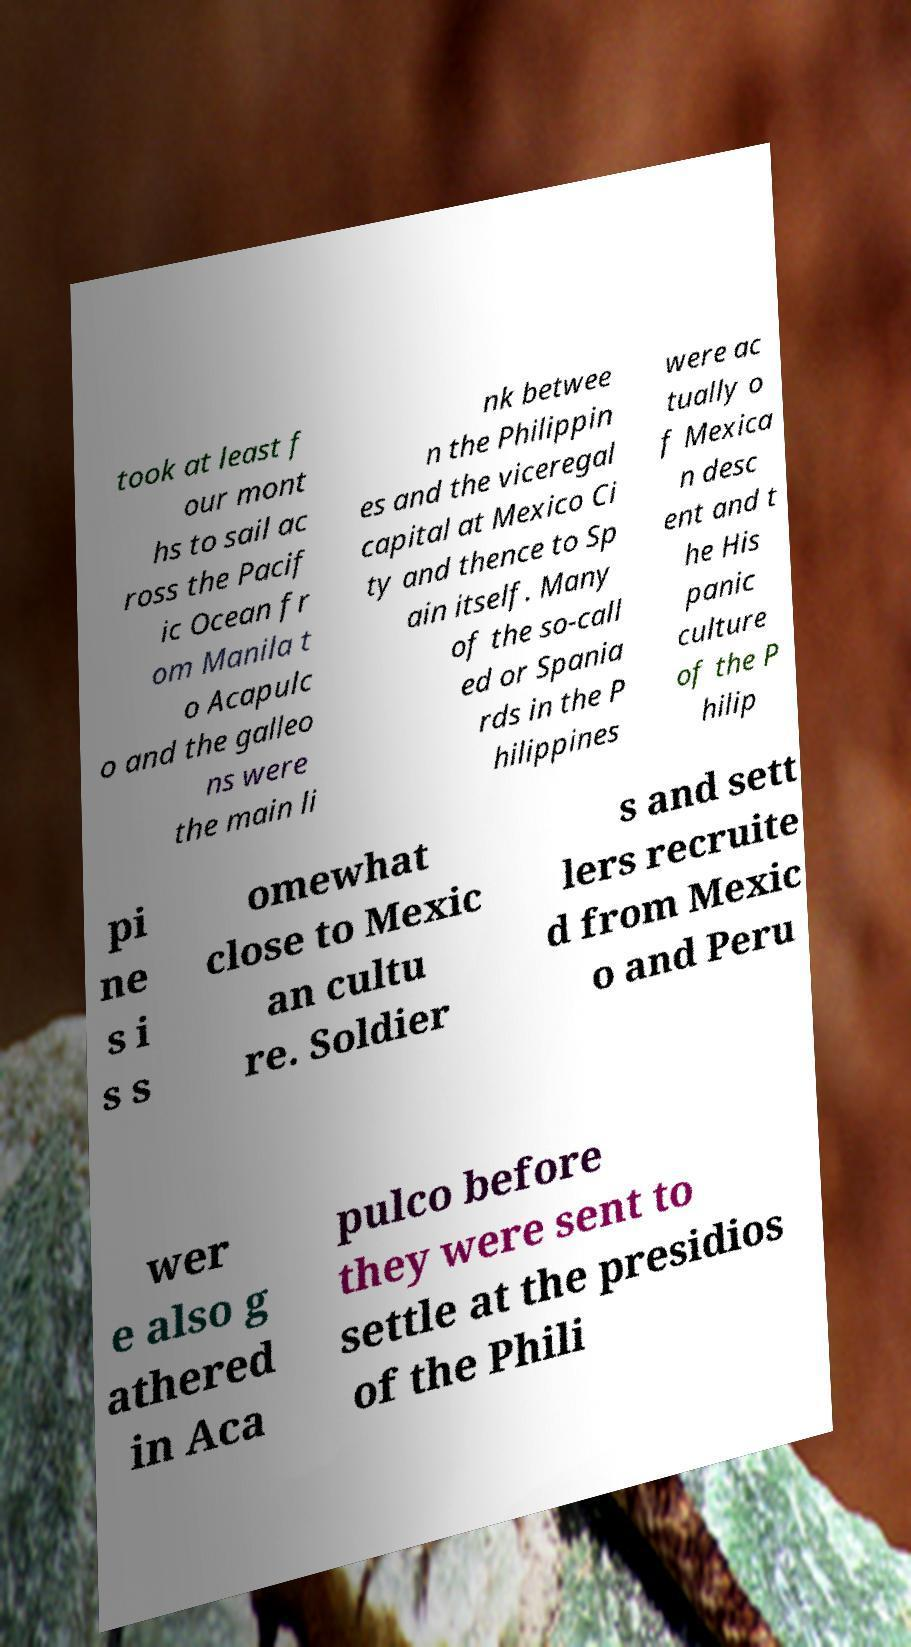For documentation purposes, I need the text within this image transcribed. Could you provide that? took at least f our mont hs to sail ac ross the Pacif ic Ocean fr om Manila t o Acapulc o and the galleo ns were the main li nk betwee n the Philippin es and the viceregal capital at Mexico Ci ty and thence to Sp ain itself. Many of the so-call ed or Spania rds in the P hilippines were ac tually o f Mexica n desc ent and t he His panic culture of the P hilip pi ne s i s s omewhat close to Mexic an cultu re. Soldier s and sett lers recruite d from Mexic o and Peru wer e also g athered in Aca pulco before they were sent to settle at the presidios of the Phili 